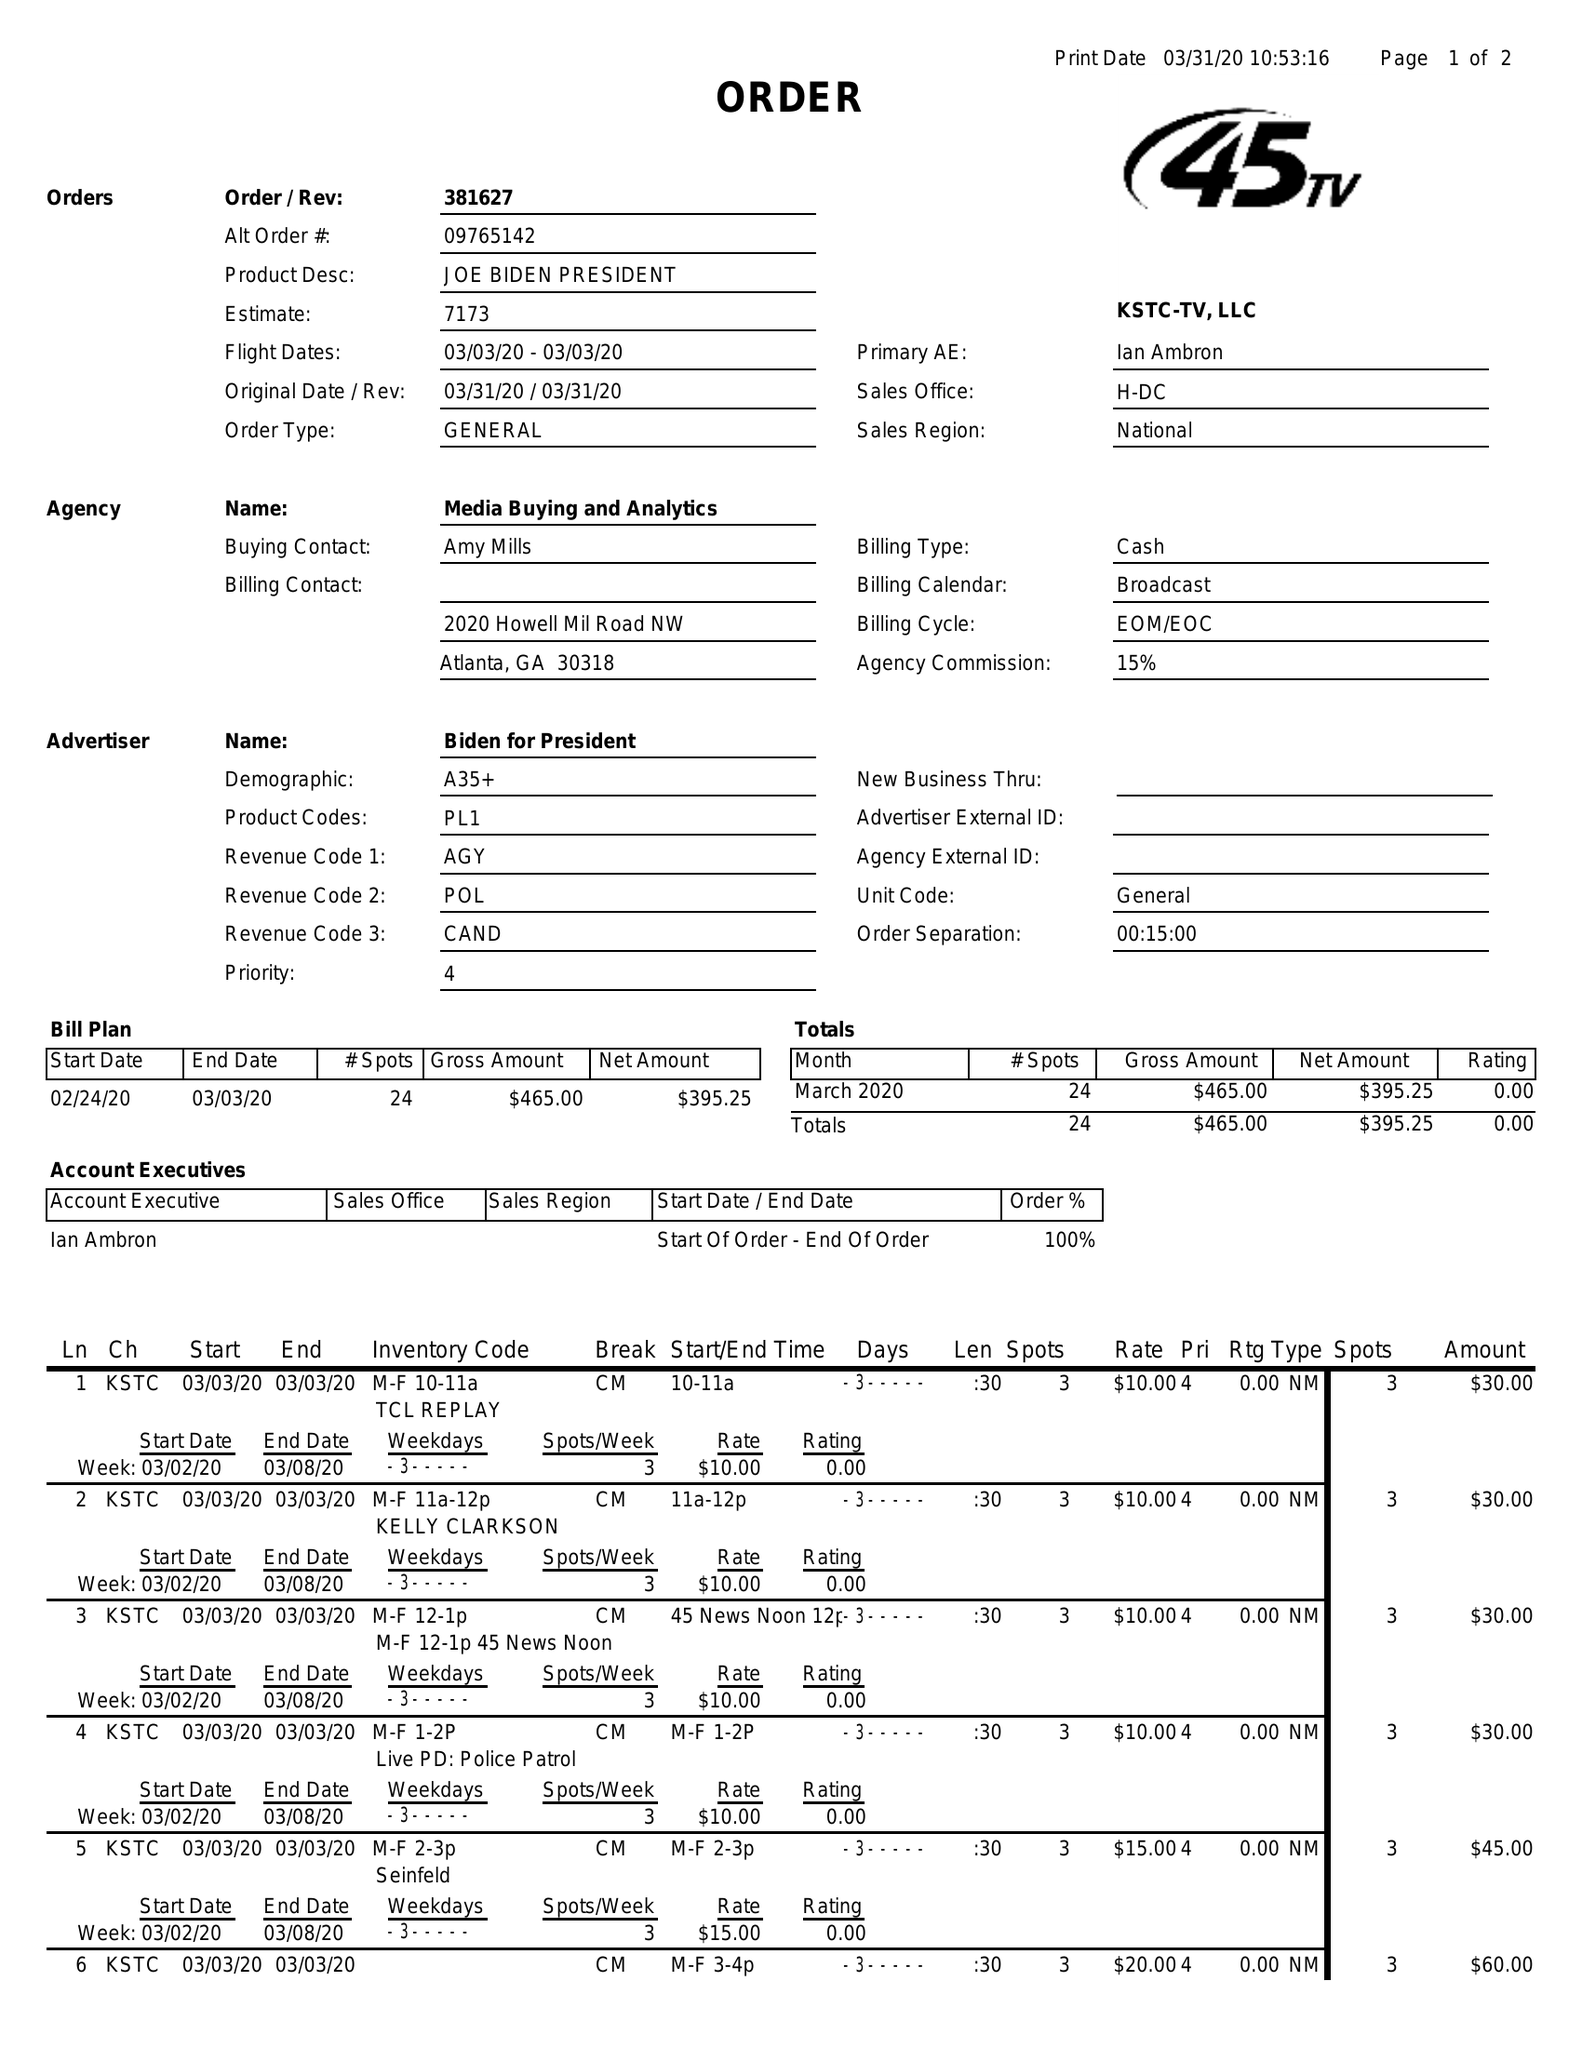What is the value for the advertiser?
Answer the question using a single word or phrase. BIDEN FOR PRESIDENT 